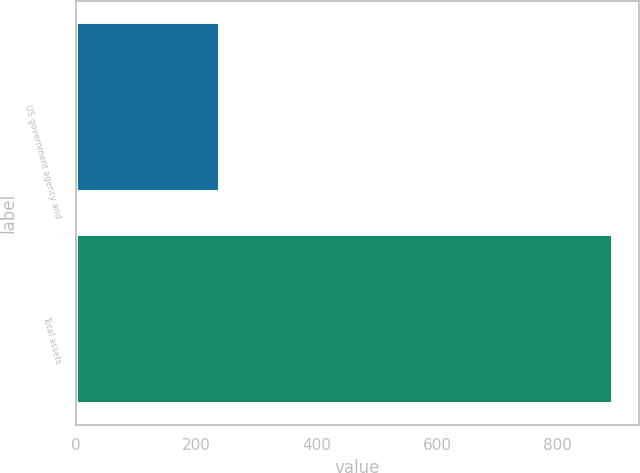Convert chart to OTSL. <chart><loc_0><loc_0><loc_500><loc_500><bar_chart><fcel>US government agency and<fcel>Total assets<nl><fcel>240<fcel>891<nl></chart> 